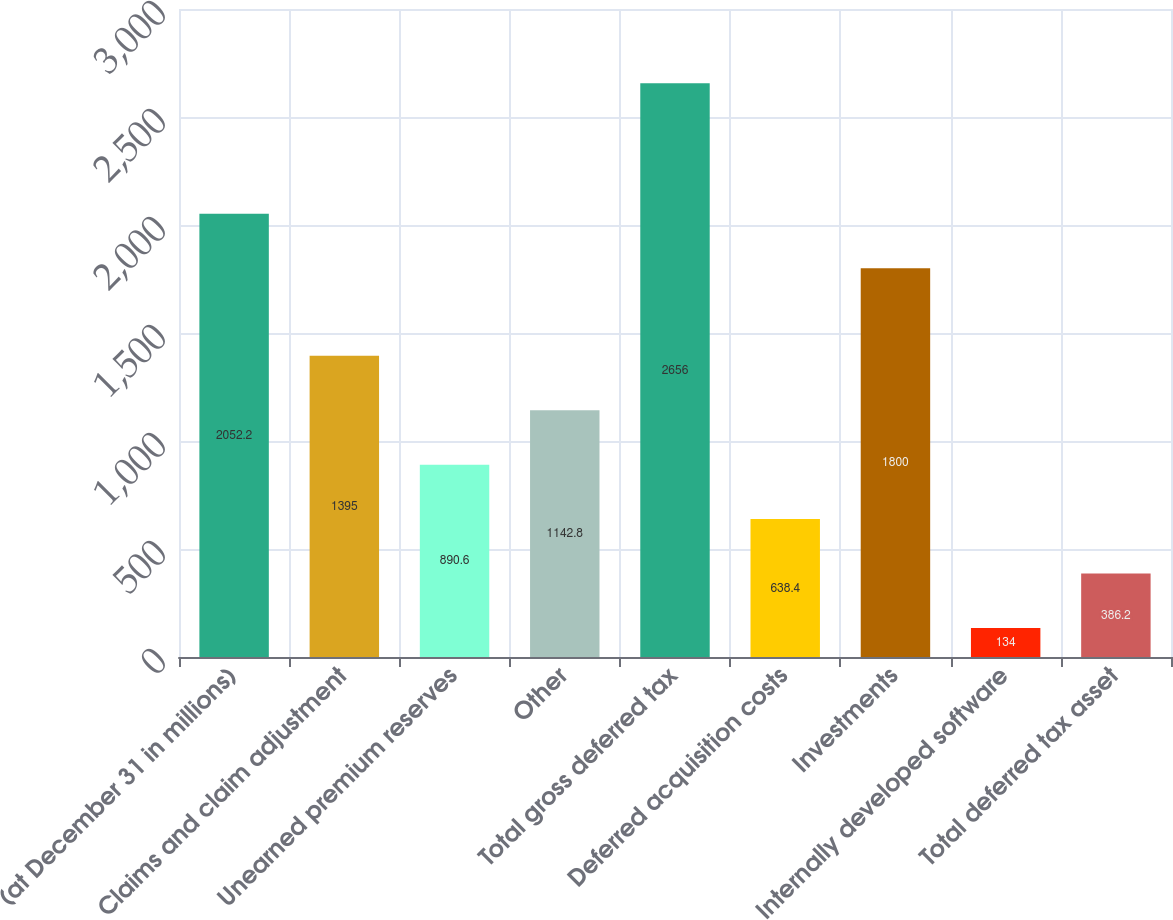Convert chart. <chart><loc_0><loc_0><loc_500><loc_500><bar_chart><fcel>(at December 31 in millions)<fcel>Claims and claim adjustment<fcel>Unearned premium reserves<fcel>Other<fcel>Total gross deferred tax<fcel>Deferred acquisition costs<fcel>Investments<fcel>Internally developed software<fcel>Total deferred tax asset<nl><fcel>2052.2<fcel>1395<fcel>890.6<fcel>1142.8<fcel>2656<fcel>638.4<fcel>1800<fcel>134<fcel>386.2<nl></chart> 